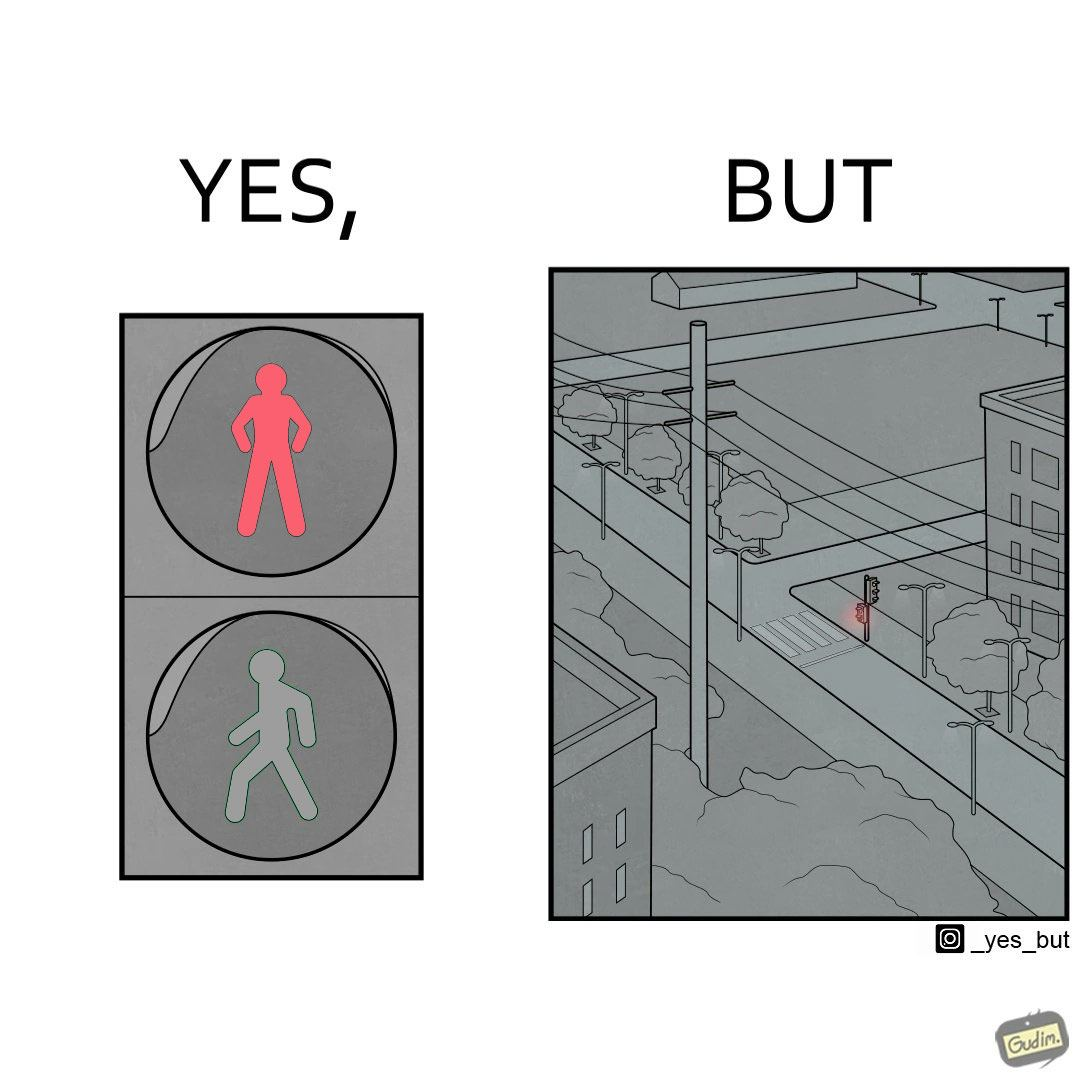Compare the left and right sides of this image. In the left part of the image: red traffic light for stopping a person from crossing the street. In the right part of the image: a red traffic light at a zebra crossing, with no persons or vehicles around. 